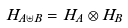<formula> <loc_0><loc_0><loc_500><loc_500>H _ { A \uplus B } = H _ { A } \otimes H _ { B }</formula> 